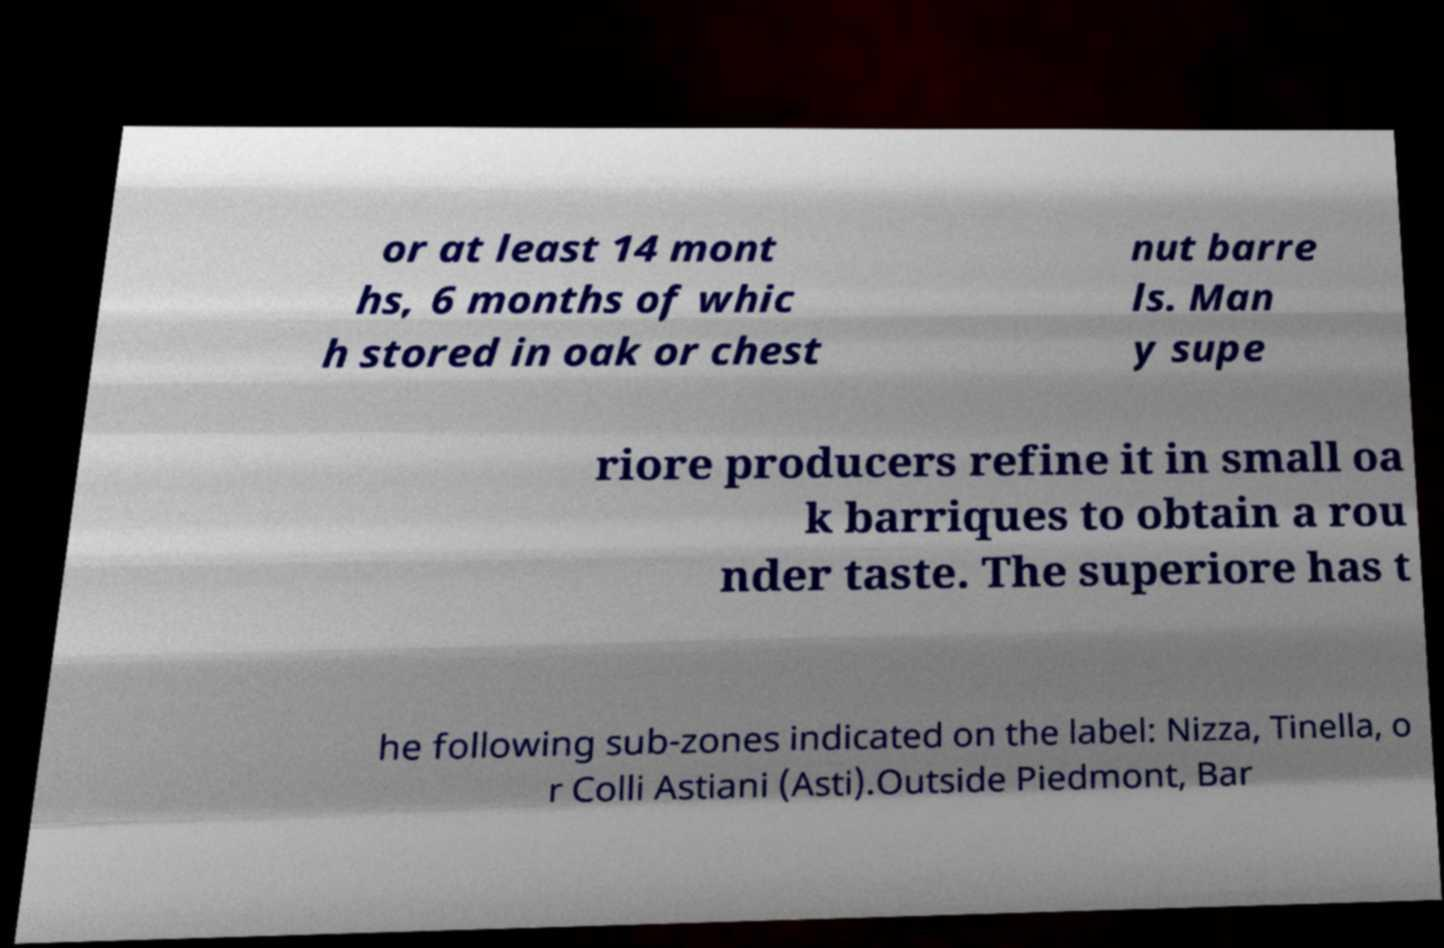I need the written content from this picture converted into text. Can you do that? or at least 14 mont hs, 6 months of whic h stored in oak or chest nut barre ls. Man y supe riore producers refine it in small oa k barriques to obtain a rou nder taste. The superiore has t he following sub-zones indicated on the label: Nizza, Tinella, o r Colli Astiani (Asti).Outside Piedmont, Bar 